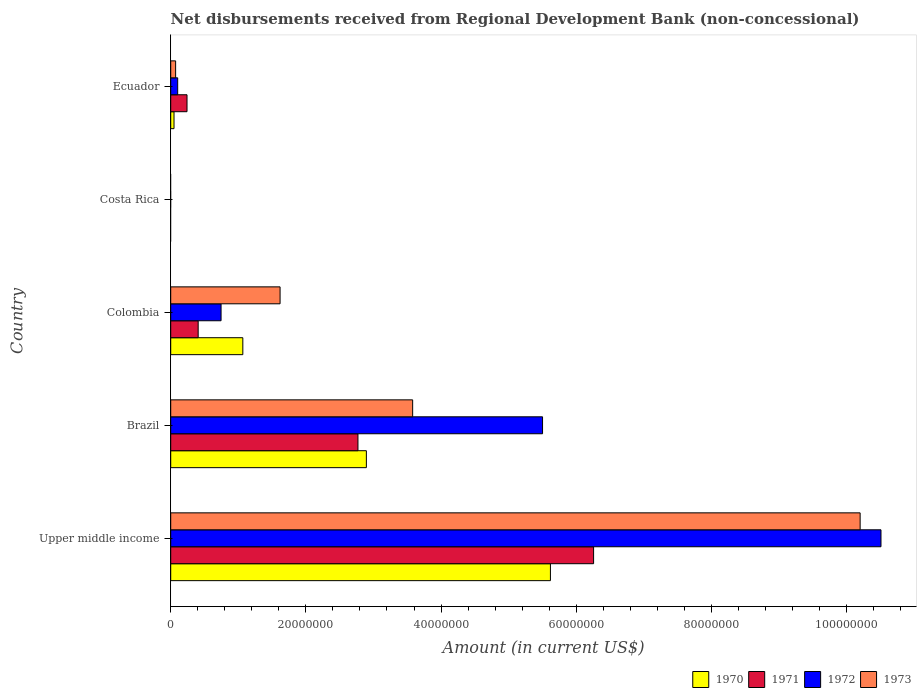How many different coloured bars are there?
Your response must be concise. 4. Are the number of bars per tick equal to the number of legend labels?
Keep it short and to the point. No. How many bars are there on the 2nd tick from the top?
Your response must be concise. 0. What is the label of the 2nd group of bars from the top?
Make the answer very short. Costa Rica. What is the amount of disbursements received from Regional Development Bank in 1973 in Upper middle income?
Keep it short and to the point. 1.02e+08. Across all countries, what is the maximum amount of disbursements received from Regional Development Bank in 1973?
Your answer should be very brief. 1.02e+08. Across all countries, what is the minimum amount of disbursements received from Regional Development Bank in 1972?
Your answer should be compact. 0. In which country was the amount of disbursements received from Regional Development Bank in 1970 maximum?
Your response must be concise. Upper middle income. What is the total amount of disbursements received from Regional Development Bank in 1970 in the graph?
Offer a terse response. 9.63e+07. What is the difference between the amount of disbursements received from Regional Development Bank in 1971 in Colombia and that in Upper middle income?
Provide a short and direct response. -5.85e+07. What is the difference between the amount of disbursements received from Regional Development Bank in 1973 in Brazil and the amount of disbursements received from Regional Development Bank in 1970 in Ecuador?
Provide a succinct answer. 3.53e+07. What is the average amount of disbursements received from Regional Development Bank in 1973 per country?
Your response must be concise. 3.09e+07. What is the difference between the amount of disbursements received from Regional Development Bank in 1972 and amount of disbursements received from Regional Development Bank in 1973 in Brazil?
Give a very brief answer. 1.92e+07. In how many countries, is the amount of disbursements received from Regional Development Bank in 1970 greater than 16000000 US$?
Offer a terse response. 2. What is the ratio of the amount of disbursements received from Regional Development Bank in 1970 in Brazil to that in Upper middle income?
Keep it short and to the point. 0.52. What is the difference between the highest and the second highest amount of disbursements received from Regional Development Bank in 1970?
Provide a short and direct response. 2.72e+07. What is the difference between the highest and the lowest amount of disbursements received from Regional Development Bank in 1972?
Make the answer very short. 1.05e+08. Is it the case that in every country, the sum of the amount of disbursements received from Regional Development Bank in 1970 and amount of disbursements received from Regional Development Bank in 1973 is greater than the sum of amount of disbursements received from Regional Development Bank in 1971 and amount of disbursements received from Regional Development Bank in 1972?
Offer a very short reply. No. Are all the bars in the graph horizontal?
Offer a very short reply. Yes. How many countries are there in the graph?
Keep it short and to the point. 5. What is the difference between two consecutive major ticks on the X-axis?
Your answer should be compact. 2.00e+07. How are the legend labels stacked?
Offer a terse response. Horizontal. What is the title of the graph?
Your answer should be compact. Net disbursements received from Regional Development Bank (non-concessional). Does "1981" appear as one of the legend labels in the graph?
Your answer should be compact. No. What is the label or title of the X-axis?
Your answer should be very brief. Amount (in current US$). What is the Amount (in current US$) in 1970 in Upper middle income?
Give a very brief answer. 5.62e+07. What is the Amount (in current US$) of 1971 in Upper middle income?
Your answer should be compact. 6.26e+07. What is the Amount (in current US$) in 1972 in Upper middle income?
Ensure brevity in your answer.  1.05e+08. What is the Amount (in current US$) in 1973 in Upper middle income?
Provide a succinct answer. 1.02e+08. What is the Amount (in current US$) in 1970 in Brazil?
Give a very brief answer. 2.90e+07. What is the Amount (in current US$) in 1971 in Brazil?
Provide a succinct answer. 2.77e+07. What is the Amount (in current US$) in 1972 in Brazil?
Ensure brevity in your answer.  5.50e+07. What is the Amount (in current US$) in 1973 in Brazil?
Give a very brief answer. 3.58e+07. What is the Amount (in current US$) in 1970 in Colombia?
Ensure brevity in your answer.  1.07e+07. What is the Amount (in current US$) in 1971 in Colombia?
Provide a short and direct response. 4.06e+06. What is the Amount (in current US$) in 1972 in Colombia?
Your answer should be compact. 7.45e+06. What is the Amount (in current US$) in 1973 in Colombia?
Provide a short and direct response. 1.62e+07. What is the Amount (in current US$) in 1970 in Costa Rica?
Make the answer very short. 0. What is the Amount (in current US$) of 1971 in Costa Rica?
Your answer should be very brief. 0. What is the Amount (in current US$) of 1970 in Ecuador?
Offer a very short reply. 4.89e+05. What is the Amount (in current US$) of 1971 in Ecuador?
Your answer should be very brief. 2.41e+06. What is the Amount (in current US$) in 1972 in Ecuador?
Make the answer very short. 1.03e+06. What is the Amount (in current US$) of 1973 in Ecuador?
Ensure brevity in your answer.  7.26e+05. Across all countries, what is the maximum Amount (in current US$) in 1970?
Offer a terse response. 5.62e+07. Across all countries, what is the maximum Amount (in current US$) in 1971?
Your answer should be compact. 6.26e+07. Across all countries, what is the maximum Amount (in current US$) of 1972?
Your answer should be very brief. 1.05e+08. Across all countries, what is the maximum Amount (in current US$) in 1973?
Make the answer very short. 1.02e+08. Across all countries, what is the minimum Amount (in current US$) in 1970?
Give a very brief answer. 0. Across all countries, what is the minimum Amount (in current US$) of 1971?
Your response must be concise. 0. What is the total Amount (in current US$) in 1970 in the graph?
Offer a terse response. 9.63e+07. What is the total Amount (in current US$) of 1971 in the graph?
Offer a very short reply. 9.68e+07. What is the total Amount (in current US$) in 1972 in the graph?
Your response must be concise. 1.69e+08. What is the total Amount (in current US$) of 1973 in the graph?
Your answer should be compact. 1.55e+08. What is the difference between the Amount (in current US$) in 1970 in Upper middle income and that in Brazil?
Keep it short and to the point. 2.72e+07. What is the difference between the Amount (in current US$) of 1971 in Upper middle income and that in Brazil?
Make the answer very short. 3.49e+07. What is the difference between the Amount (in current US$) in 1972 in Upper middle income and that in Brazil?
Offer a very short reply. 5.01e+07. What is the difference between the Amount (in current US$) in 1973 in Upper middle income and that in Brazil?
Ensure brevity in your answer.  6.62e+07. What is the difference between the Amount (in current US$) in 1970 in Upper middle income and that in Colombia?
Your answer should be very brief. 4.55e+07. What is the difference between the Amount (in current US$) of 1971 in Upper middle income and that in Colombia?
Offer a very short reply. 5.85e+07. What is the difference between the Amount (in current US$) in 1972 in Upper middle income and that in Colombia?
Provide a short and direct response. 9.76e+07. What is the difference between the Amount (in current US$) of 1973 in Upper middle income and that in Colombia?
Keep it short and to the point. 8.58e+07. What is the difference between the Amount (in current US$) of 1970 in Upper middle income and that in Ecuador?
Your answer should be very brief. 5.57e+07. What is the difference between the Amount (in current US$) in 1971 in Upper middle income and that in Ecuador?
Your response must be concise. 6.02e+07. What is the difference between the Amount (in current US$) of 1972 in Upper middle income and that in Ecuador?
Offer a very short reply. 1.04e+08. What is the difference between the Amount (in current US$) in 1973 in Upper middle income and that in Ecuador?
Provide a succinct answer. 1.01e+08. What is the difference between the Amount (in current US$) in 1970 in Brazil and that in Colombia?
Ensure brevity in your answer.  1.83e+07. What is the difference between the Amount (in current US$) in 1971 in Brazil and that in Colombia?
Your response must be concise. 2.36e+07. What is the difference between the Amount (in current US$) in 1972 in Brazil and that in Colombia?
Your answer should be compact. 4.76e+07. What is the difference between the Amount (in current US$) in 1973 in Brazil and that in Colombia?
Your answer should be compact. 1.96e+07. What is the difference between the Amount (in current US$) in 1970 in Brazil and that in Ecuador?
Make the answer very short. 2.85e+07. What is the difference between the Amount (in current US$) in 1971 in Brazil and that in Ecuador?
Keep it short and to the point. 2.53e+07. What is the difference between the Amount (in current US$) in 1972 in Brazil and that in Ecuador?
Your answer should be compact. 5.40e+07. What is the difference between the Amount (in current US$) in 1973 in Brazil and that in Ecuador?
Your answer should be very brief. 3.51e+07. What is the difference between the Amount (in current US$) of 1970 in Colombia and that in Ecuador?
Your answer should be very brief. 1.02e+07. What is the difference between the Amount (in current US$) in 1971 in Colombia and that in Ecuador?
Your answer should be compact. 1.65e+06. What is the difference between the Amount (in current US$) of 1972 in Colombia and that in Ecuador?
Your response must be concise. 6.42e+06. What is the difference between the Amount (in current US$) of 1973 in Colombia and that in Ecuador?
Your response must be concise. 1.55e+07. What is the difference between the Amount (in current US$) of 1970 in Upper middle income and the Amount (in current US$) of 1971 in Brazil?
Your answer should be compact. 2.85e+07. What is the difference between the Amount (in current US$) in 1970 in Upper middle income and the Amount (in current US$) in 1972 in Brazil?
Provide a short and direct response. 1.16e+06. What is the difference between the Amount (in current US$) in 1970 in Upper middle income and the Amount (in current US$) in 1973 in Brazil?
Offer a terse response. 2.04e+07. What is the difference between the Amount (in current US$) in 1971 in Upper middle income and the Amount (in current US$) in 1972 in Brazil?
Offer a very short reply. 7.55e+06. What is the difference between the Amount (in current US$) of 1971 in Upper middle income and the Amount (in current US$) of 1973 in Brazil?
Offer a very short reply. 2.68e+07. What is the difference between the Amount (in current US$) in 1972 in Upper middle income and the Amount (in current US$) in 1973 in Brazil?
Your response must be concise. 6.93e+07. What is the difference between the Amount (in current US$) in 1970 in Upper middle income and the Amount (in current US$) in 1971 in Colombia?
Your answer should be very brief. 5.21e+07. What is the difference between the Amount (in current US$) of 1970 in Upper middle income and the Amount (in current US$) of 1972 in Colombia?
Provide a short and direct response. 4.87e+07. What is the difference between the Amount (in current US$) of 1970 in Upper middle income and the Amount (in current US$) of 1973 in Colombia?
Ensure brevity in your answer.  4.00e+07. What is the difference between the Amount (in current US$) of 1971 in Upper middle income and the Amount (in current US$) of 1972 in Colombia?
Keep it short and to the point. 5.51e+07. What is the difference between the Amount (in current US$) in 1971 in Upper middle income and the Amount (in current US$) in 1973 in Colombia?
Ensure brevity in your answer.  4.64e+07. What is the difference between the Amount (in current US$) of 1972 in Upper middle income and the Amount (in current US$) of 1973 in Colombia?
Offer a very short reply. 8.89e+07. What is the difference between the Amount (in current US$) in 1970 in Upper middle income and the Amount (in current US$) in 1971 in Ecuador?
Provide a short and direct response. 5.38e+07. What is the difference between the Amount (in current US$) of 1970 in Upper middle income and the Amount (in current US$) of 1972 in Ecuador?
Your answer should be very brief. 5.52e+07. What is the difference between the Amount (in current US$) in 1970 in Upper middle income and the Amount (in current US$) in 1973 in Ecuador?
Offer a very short reply. 5.55e+07. What is the difference between the Amount (in current US$) in 1971 in Upper middle income and the Amount (in current US$) in 1972 in Ecuador?
Ensure brevity in your answer.  6.15e+07. What is the difference between the Amount (in current US$) in 1971 in Upper middle income and the Amount (in current US$) in 1973 in Ecuador?
Offer a very short reply. 6.18e+07. What is the difference between the Amount (in current US$) of 1972 in Upper middle income and the Amount (in current US$) of 1973 in Ecuador?
Keep it short and to the point. 1.04e+08. What is the difference between the Amount (in current US$) of 1970 in Brazil and the Amount (in current US$) of 1971 in Colombia?
Provide a short and direct response. 2.49e+07. What is the difference between the Amount (in current US$) in 1970 in Brazil and the Amount (in current US$) in 1972 in Colombia?
Your answer should be compact. 2.15e+07. What is the difference between the Amount (in current US$) in 1970 in Brazil and the Amount (in current US$) in 1973 in Colombia?
Provide a short and direct response. 1.28e+07. What is the difference between the Amount (in current US$) of 1971 in Brazil and the Amount (in current US$) of 1972 in Colombia?
Make the answer very short. 2.03e+07. What is the difference between the Amount (in current US$) in 1971 in Brazil and the Amount (in current US$) in 1973 in Colombia?
Offer a very short reply. 1.15e+07. What is the difference between the Amount (in current US$) of 1972 in Brazil and the Amount (in current US$) of 1973 in Colombia?
Ensure brevity in your answer.  3.88e+07. What is the difference between the Amount (in current US$) of 1970 in Brazil and the Amount (in current US$) of 1971 in Ecuador?
Keep it short and to the point. 2.65e+07. What is the difference between the Amount (in current US$) in 1970 in Brazil and the Amount (in current US$) in 1972 in Ecuador?
Offer a very short reply. 2.79e+07. What is the difference between the Amount (in current US$) of 1970 in Brazil and the Amount (in current US$) of 1973 in Ecuador?
Provide a succinct answer. 2.82e+07. What is the difference between the Amount (in current US$) in 1971 in Brazil and the Amount (in current US$) in 1972 in Ecuador?
Give a very brief answer. 2.67e+07. What is the difference between the Amount (in current US$) of 1971 in Brazil and the Amount (in current US$) of 1973 in Ecuador?
Give a very brief answer. 2.70e+07. What is the difference between the Amount (in current US$) of 1972 in Brazil and the Amount (in current US$) of 1973 in Ecuador?
Provide a short and direct response. 5.43e+07. What is the difference between the Amount (in current US$) in 1970 in Colombia and the Amount (in current US$) in 1971 in Ecuador?
Offer a terse response. 8.26e+06. What is the difference between the Amount (in current US$) in 1970 in Colombia and the Amount (in current US$) in 1972 in Ecuador?
Keep it short and to the point. 9.64e+06. What is the difference between the Amount (in current US$) in 1970 in Colombia and the Amount (in current US$) in 1973 in Ecuador?
Offer a terse response. 9.94e+06. What is the difference between the Amount (in current US$) of 1971 in Colombia and the Amount (in current US$) of 1972 in Ecuador?
Your response must be concise. 3.03e+06. What is the difference between the Amount (in current US$) of 1971 in Colombia and the Amount (in current US$) of 1973 in Ecuador?
Your response must be concise. 3.34e+06. What is the difference between the Amount (in current US$) of 1972 in Colombia and the Amount (in current US$) of 1973 in Ecuador?
Make the answer very short. 6.72e+06. What is the average Amount (in current US$) of 1970 per country?
Your response must be concise. 1.93e+07. What is the average Amount (in current US$) of 1971 per country?
Provide a short and direct response. 1.94e+07. What is the average Amount (in current US$) in 1972 per country?
Your answer should be very brief. 3.37e+07. What is the average Amount (in current US$) in 1973 per country?
Provide a succinct answer. 3.09e+07. What is the difference between the Amount (in current US$) of 1970 and Amount (in current US$) of 1971 in Upper middle income?
Offer a terse response. -6.39e+06. What is the difference between the Amount (in current US$) in 1970 and Amount (in current US$) in 1972 in Upper middle income?
Provide a short and direct response. -4.89e+07. What is the difference between the Amount (in current US$) of 1970 and Amount (in current US$) of 1973 in Upper middle income?
Keep it short and to the point. -4.58e+07. What is the difference between the Amount (in current US$) in 1971 and Amount (in current US$) in 1972 in Upper middle income?
Offer a terse response. -4.25e+07. What is the difference between the Amount (in current US$) of 1971 and Amount (in current US$) of 1973 in Upper middle income?
Give a very brief answer. -3.94e+07. What is the difference between the Amount (in current US$) in 1972 and Amount (in current US$) in 1973 in Upper middle income?
Your answer should be compact. 3.08e+06. What is the difference between the Amount (in current US$) of 1970 and Amount (in current US$) of 1971 in Brazil?
Your answer should be compact. 1.25e+06. What is the difference between the Amount (in current US$) in 1970 and Amount (in current US$) in 1972 in Brazil?
Offer a very short reply. -2.61e+07. What is the difference between the Amount (in current US$) in 1970 and Amount (in current US$) in 1973 in Brazil?
Your answer should be very brief. -6.85e+06. What is the difference between the Amount (in current US$) in 1971 and Amount (in current US$) in 1972 in Brazil?
Offer a very short reply. -2.73e+07. What is the difference between the Amount (in current US$) in 1971 and Amount (in current US$) in 1973 in Brazil?
Provide a succinct answer. -8.10e+06. What is the difference between the Amount (in current US$) of 1972 and Amount (in current US$) of 1973 in Brazil?
Provide a short and direct response. 1.92e+07. What is the difference between the Amount (in current US$) of 1970 and Amount (in current US$) of 1971 in Colombia?
Keep it short and to the point. 6.61e+06. What is the difference between the Amount (in current US$) of 1970 and Amount (in current US$) of 1972 in Colombia?
Ensure brevity in your answer.  3.22e+06. What is the difference between the Amount (in current US$) of 1970 and Amount (in current US$) of 1973 in Colombia?
Make the answer very short. -5.51e+06. What is the difference between the Amount (in current US$) in 1971 and Amount (in current US$) in 1972 in Colombia?
Give a very brief answer. -3.39e+06. What is the difference between the Amount (in current US$) of 1971 and Amount (in current US$) of 1973 in Colombia?
Offer a terse response. -1.21e+07. What is the difference between the Amount (in current US$) of 1972 and Amount (in current US$) of 1973 in Colombia?
Provide a short and direct response. -8.73e+06. What is the difference between the Amount (in current US$) of 1970 and Amount (in current US$) of 1971 in Ecuador?
Your answer should be compact. -1.92e+06. What is the difference between the Amount (in current US$) of 1970 and Amount (in current US$) of 1972 in Ecuador?
Offer a terse response. -5.42e+05. What is the difference between the Amount (in current US$) in 1970 and Amount (in current US$) in 1973 in Ecuador?
Keep it short and to the point. -2.37e+05. What is the difference between the Amount (in current US$) in 1971 and Amount (in current US$) in 1972 in Ecuador?
Offer a very short reply. 1.38e+06. What is the difference between the Amount (in current US$) in 1971 and Amount (in current US$) in 1973 in Ecuador?
Make the answer very short. 1.68e+06. What is the difference between the Amount (in current US$) in 1972 and Amount (in current US$) in 1973 in Ecuador?
Your answer should be very brief. 3.05e+05. What is the ratio of the Amount (in current US$) of 1970 in Upper middle income to that in Brazil?
Make the answer very short. 1.94. What is the ratio of the Amount (in current US$) in 1971 in Upper middle income to that in Brazil?
Your response must be concise. 2.26. What is the ratio of the Amount (in current US$) of 1972 in Upper middle income to that in Brazil?
Your answer should be compact. 1.91. What is the ratio of the Amount (in current US$) in 1973 in Upper middle income to that in Brazil?
Provide a short and direct response. 2.85. What is the ratio of the Amount (in current US$) in 1970 in Upper middle income to that in Colombia?
Provide a succinct answer. 5.27. What is the ratio of the Amount (in current US$) of 1971 in Upper middle income to that in Colombia?
Your answer should be compact. 15.4. What is the ratio of the Amount (in current US$) in 1972 in Upper middle income to that in Colombia?
Provide a succinct answer. 14.11. What is the ratio of the Amount (in current US$) in 1973 in Upper middle income to that in Colombia?
Make the answer very short. 6.3. What is the ratio of the Amount (in current US$) in 1970 in Upper middle income to that in Ecuador?
Your answer should be compact. 114.9. What is the ratio of the Amount (in current US$) of 1971 in Upper middle income to that in Ecuador?
Your answer should be very brief. 25.95. What is the ratio of the Amount (in current US$) of 1972 in Upper middle income to that in Ecuador?
Provide a short and direct response. 101.94. What is the ratio of the Amount (in current US$) of 1973 in Upper middle income to that in Ecuador?
Offer a terse response. 140.52. What is the ratio of the Amount (in current US$) in 1970 in Brazil to that in Colombia?
Offer a very short reply. 2.71. What is the ratio of the Amount (in current US$) in 1971 in Brazil to that in Colombia?
Your answer should be very brief. 6.82. What is the ratio of the Amount (in current US$) in 1972 in Brazil to that in Colombia?
Your response must be concise. 7.39. What is the ratio of the Amount (in current US$) of 1973 in Brazil to that in Colombia?
Your answer should be compact. 2.21. What is the ratio of the Amount (in current US$) in 1970 in Brazil to that in Ecuador?
Provide a succinct answer. 59.21. What is the ratio of the Amount (in current US$) of 1971 in Brazil to that in Ecuador?
Your answer should be very brief. 11.49. What is the ratio of the Amount (in current US$) of 1972 in Brazil to that in Ecuador?
Provide a succinct answer. 53.37. What is the ratio of the Amount (in current US$) in 1973 in Brazil to that in Ecuador?
Keep it short and to the point. 49.31. What is the ratio of the Amount (in current US$) in 1970 in Colombia to that in Ecuador?
Ensure brevity in your answer.  21.82. What is the ratio of the Amount (in current US$) of 1971 in Colombia to that in Ecuador?
Your response must be concise. 1.68. What is the ratio of the Amount (in current US$) in 1972 in Colombia to that in Ecuador?
Offer a very short reply. 7.23. What is the ratio of the Amount (in current US$) of 1973 in Colombia to that in Ecuador?
Your answer should be compact. 22.29. What is the difference between the highest and the second highest Amount (in current US$) of 1970?
Keep it short and to the point. 2.72e+07. What is the difference between the highest and the second highest Amount (in current US$) of 1971?
Provide a short and direct response. 3.49e+07. What is the difference between the highest and the second highest Amount (in current US$) of 1972?
Provide a succinct answer. 5.01e+07. What is the difference between the highest and the second highest Amount (in current US$) in 1973?
Give a very brief answer. 6.62e+07. What is the difference between the highest and the lowest Amount (in current US$) of 1970?
Offer a very short reply. 5.62e+07. What is the difference between the highest and the lowest Amount (in current US$) of 1971?
Provide a succinct answer. 6.26e+07. What is the difference between the highest and the lowest Amount (in current US$) of 1972?
Your answer should be compact. 1.05e+08. What is the difference between the highest and the lowest Amount (in current US$) of 1973?
Provide a short and direct response. 1.02e+08. 